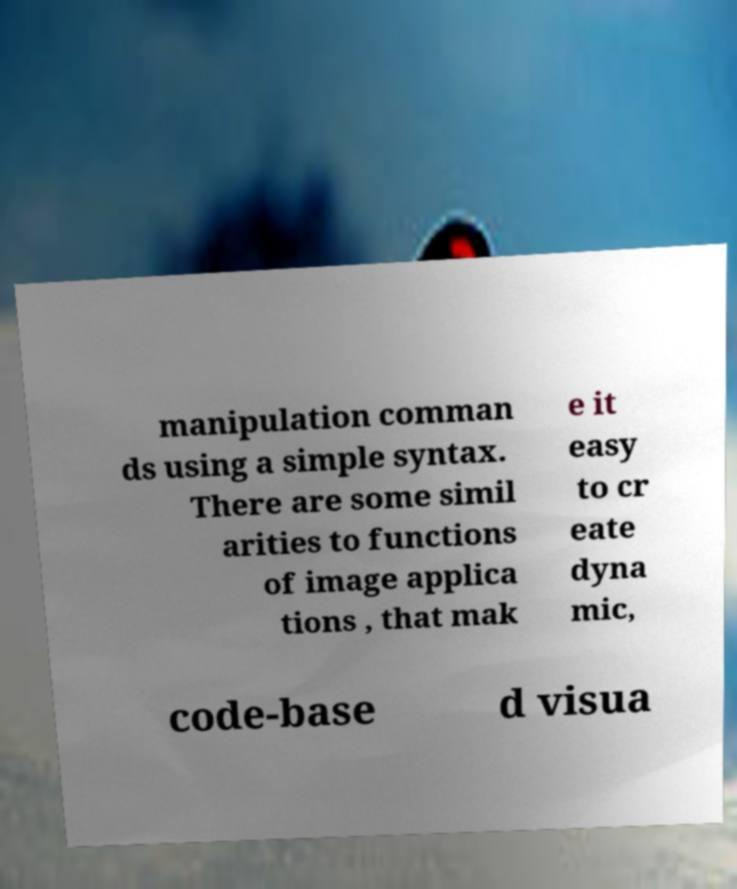Can you accurately transcribe the text from the provided image for me? manipulation comman ds using a simple syntax. There are some simil arities to functions of image applica tions , that mak e it easy to cr eate dyna mic, code-base d visua 